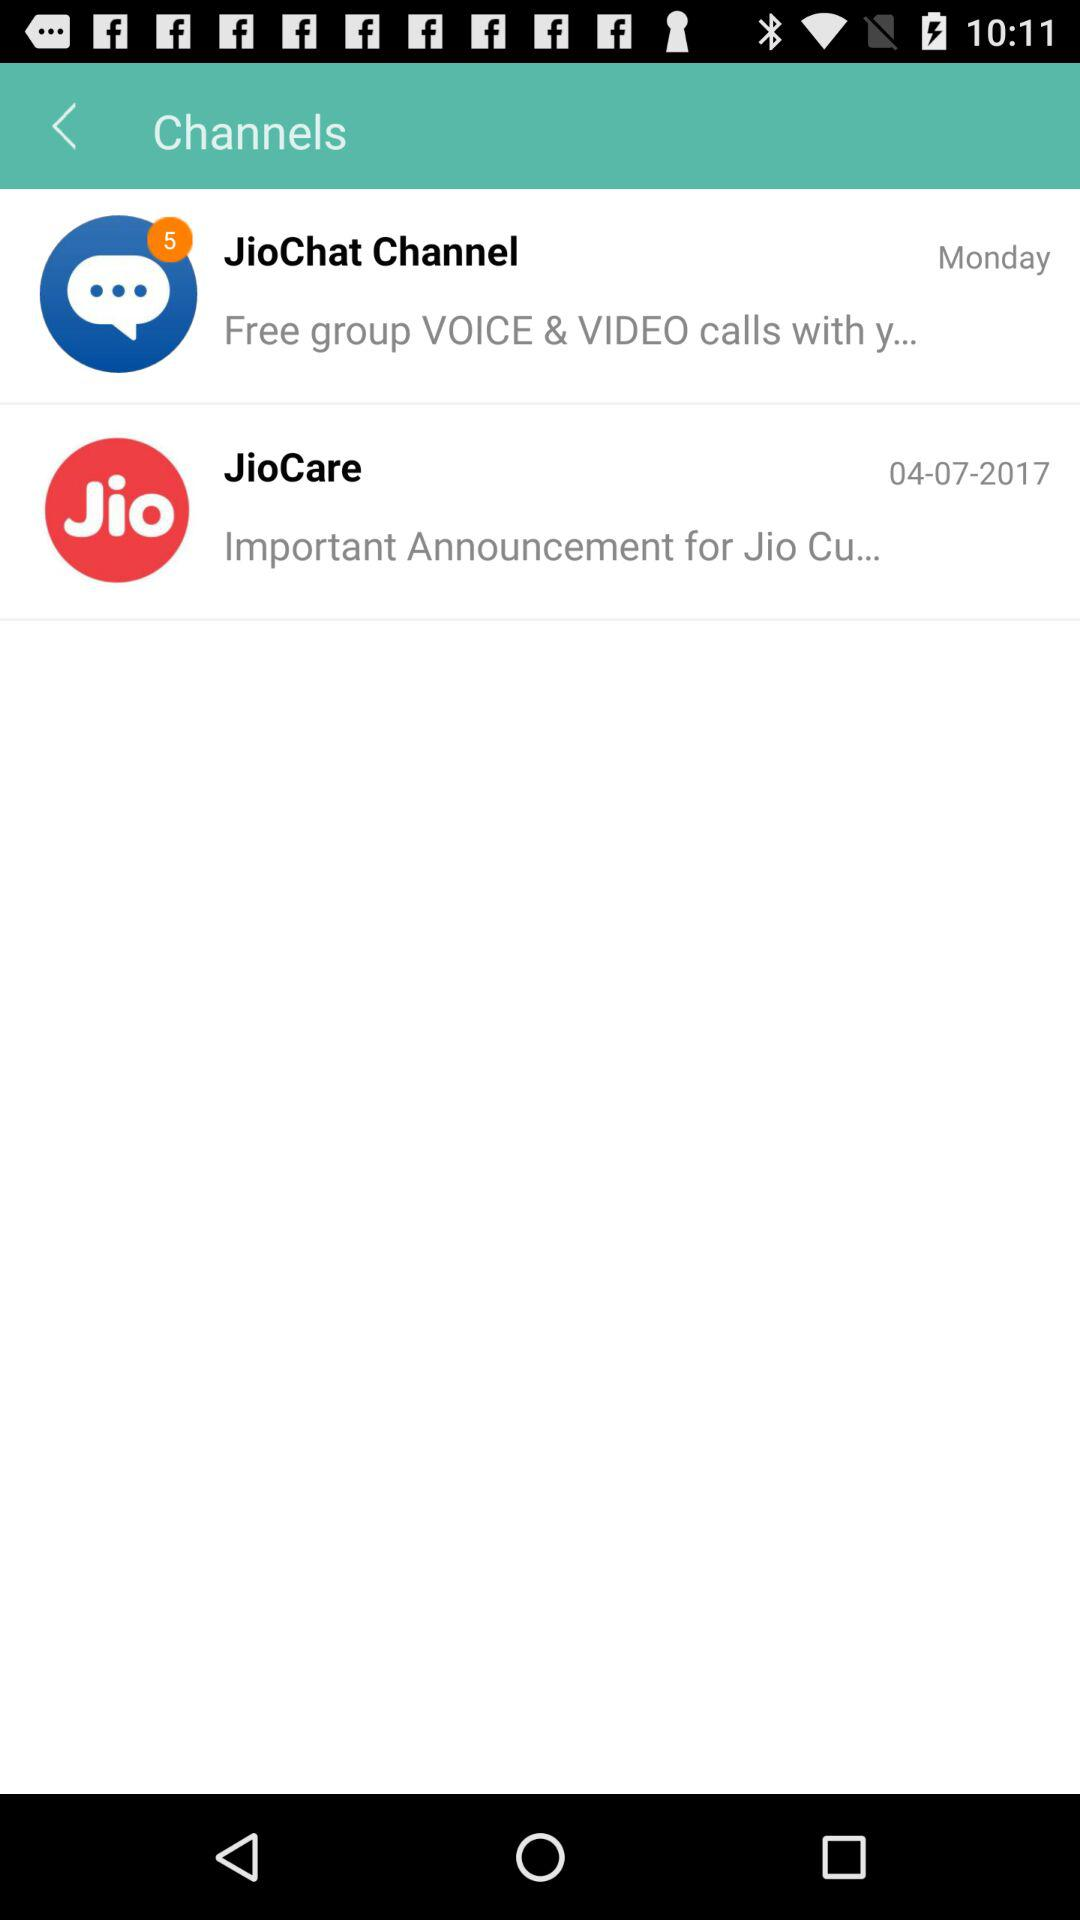What is the use of "JioChat"? The use of "JioChat" is "Free group VOICE & VIDEO calls with y...". 